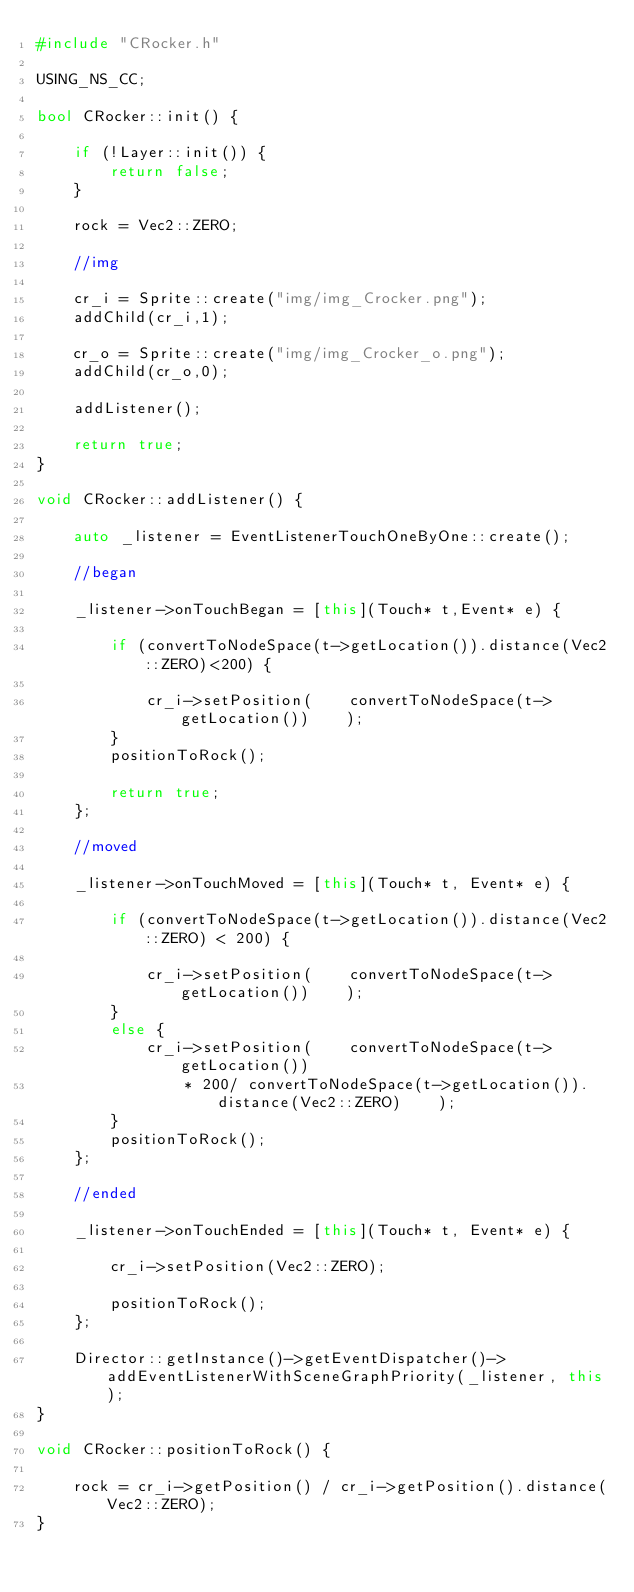Convert code to text. <code><loc_0><loc_0><loc_500><loc_500><_C++_>#include "CRocker.h"

USING_NS_CC;

bool CRocker::init() {

	if (!Layer::init()) {
		return false;
	}

	rock = Vec2::ZERO;

	//img

	cr_i = Sprite::create("img/img_Crocker.png");
	addChild(cr_i,1);

	cr_o = Sprite::create("img/img_Crocker_o.png");
	addChild(cr_o,0);

	addListener();
	
	return true;
}

void CRocker::addListener() {

	auto _listener = EventListenerTouchOneByOne::create();

	//began

	_listener->onTouchBegan = [this](Touch* t,Event* e) {

		if (convertToNodeSpace(t->getLocation()).distance(Vec2::ZERO)<200) {

			cr_i->setPosition(    convertToNodeSpace(t->getLocation())    );
		}
		positionToRock();

		return true;
	};

	//moved

	_listener->onTouchMoved = [this](Touch* t, Event* e) {

		if (convertToNodeSpace(t->getLocation()).distance(Vec2::ZERO) < 200) {

			cr_i->setPosition(    convertToNodeSpace(t->getLocation())    );
		}
		else {
			cr_i->setPosition(    convertToNodeSpace(t->getLocation()) 
				* 200/ convertToNodeSpace(t->getLocation()).distance(Vec2::ZERO)    );
		}
		positionToRock();
	};

	//ended

	_listener->onTouchEnded = [this](Touch* t, Event* e) {

		cr_i->setPosition(Vec2::ZERO);

		positionToRock();
	};

	Director::getInstance()->getEventDispatcher()->addEventListenerWithSceneGraphPriority(_listener, this);
}

void CRocker::positionToRock() {

	rock = cr_i->getPosition() / cr_i->getPosition().distance(Vec2::ZERO);
}</code> 